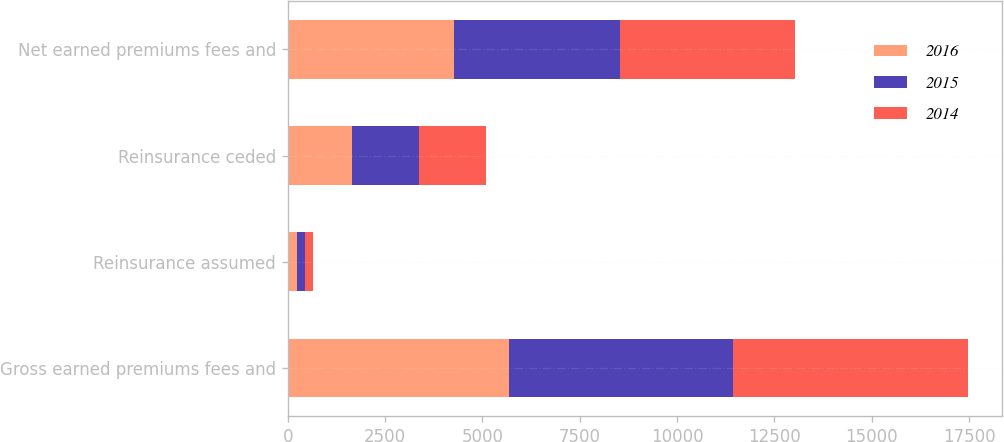Convert chart to OTSL. <chart><loc_0><loc_0><loc_500><loc_500><stacked_bar_chart><ecel><fcel>Gross earned premiums fees and<fcel>Reinsurance assumed<fcel>Reinsurance ceded<fcel>Net earned premiums fees and<nl><fcel>2016<fcel>5682<fcel>236<fcel>1651<fcel>4267<nl><fcel>2015<fcel>5767<fcel>209<fcel>1707<fcel>4269<nl><fcel>2014<fcel>6029<fcel>193<fcel>1720<fcel>4502<nl></chart> 